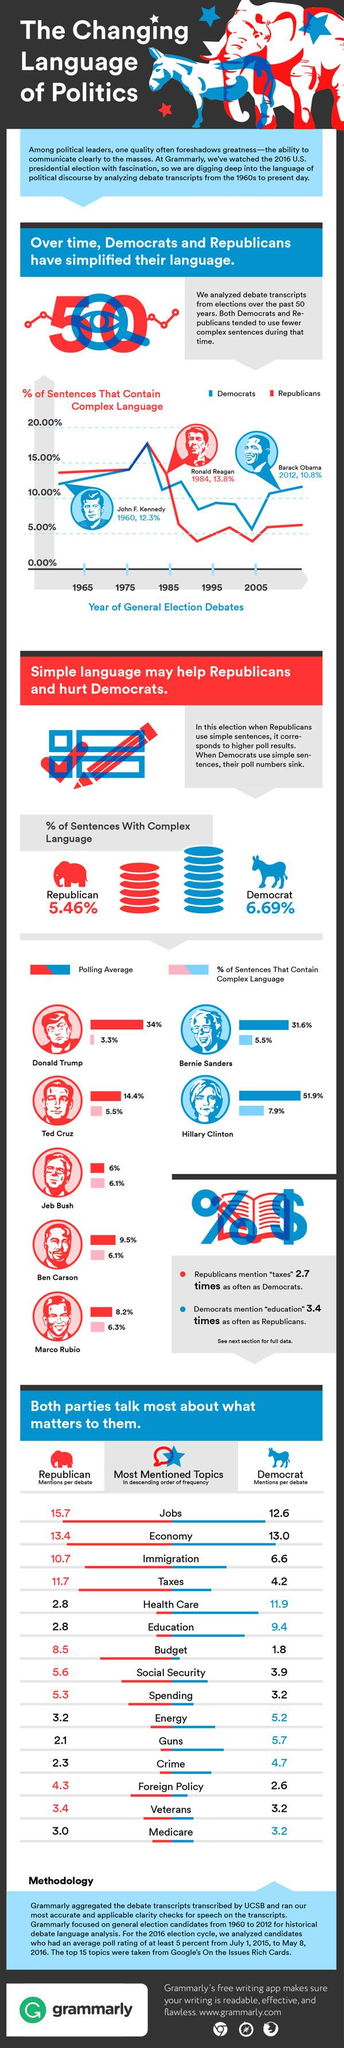Identify some key points in this picture. Hillary Clinton was the only female candidate who ran in the General Elections of 2016. During the Democratic debates, health care was the most frequently discussed topic among the candidates. Barack Obama used a simple language during general election debates, as compared to Kennedy and Reagan. In 2005, the Republican party used fewer complex sentences than the opposing party. Donald Trump had the lowest percentage of complex sentences during polls. 